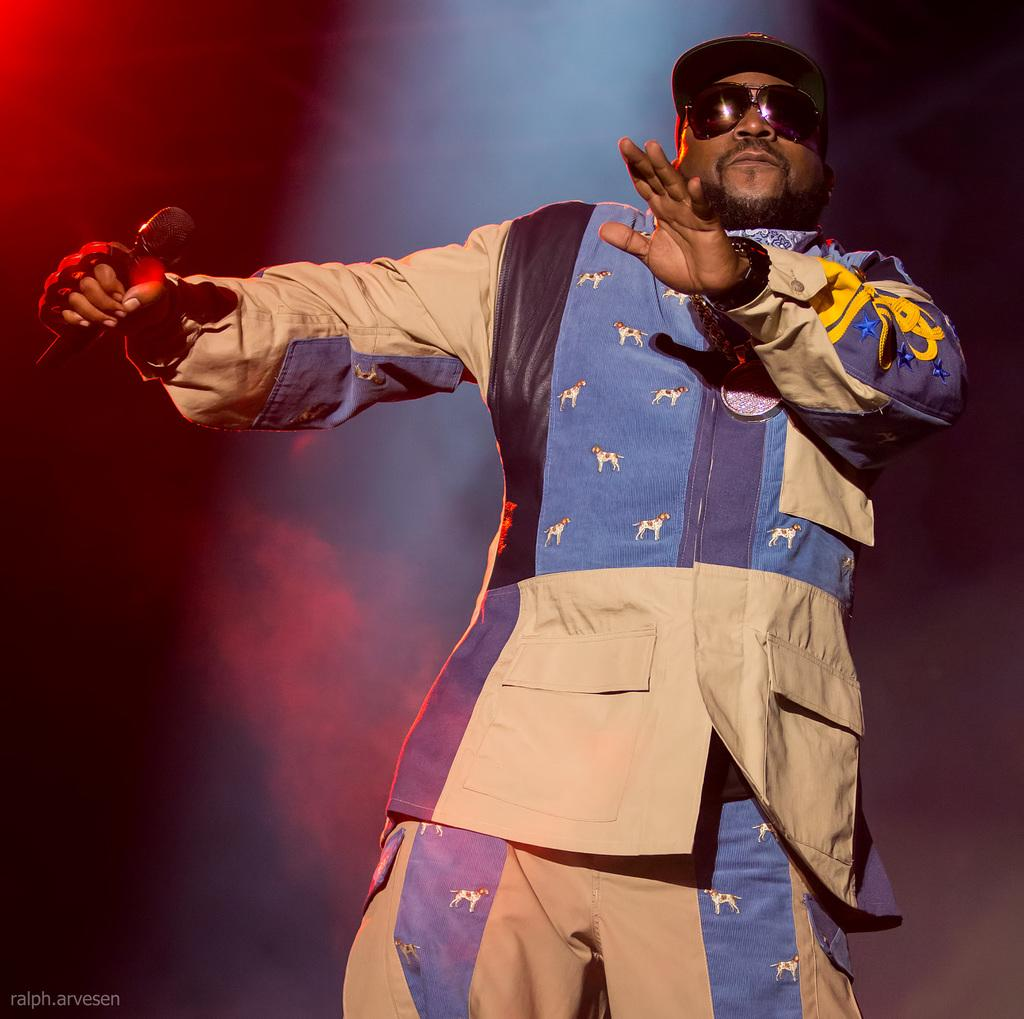What is the person in the image doing? The person in the image is holding a microphone. What else can be seen at the bottom of the image? There is some text at the bottom of the image. Can you describe the attire of the person in the image? A person is wearing a cap and spectacles in the image. What type of idea can be seen floating in the image? There is no idea visible in the image; it only features a person holding a microphone, text at the bottom, and a person wearing a cap and spectacles. 